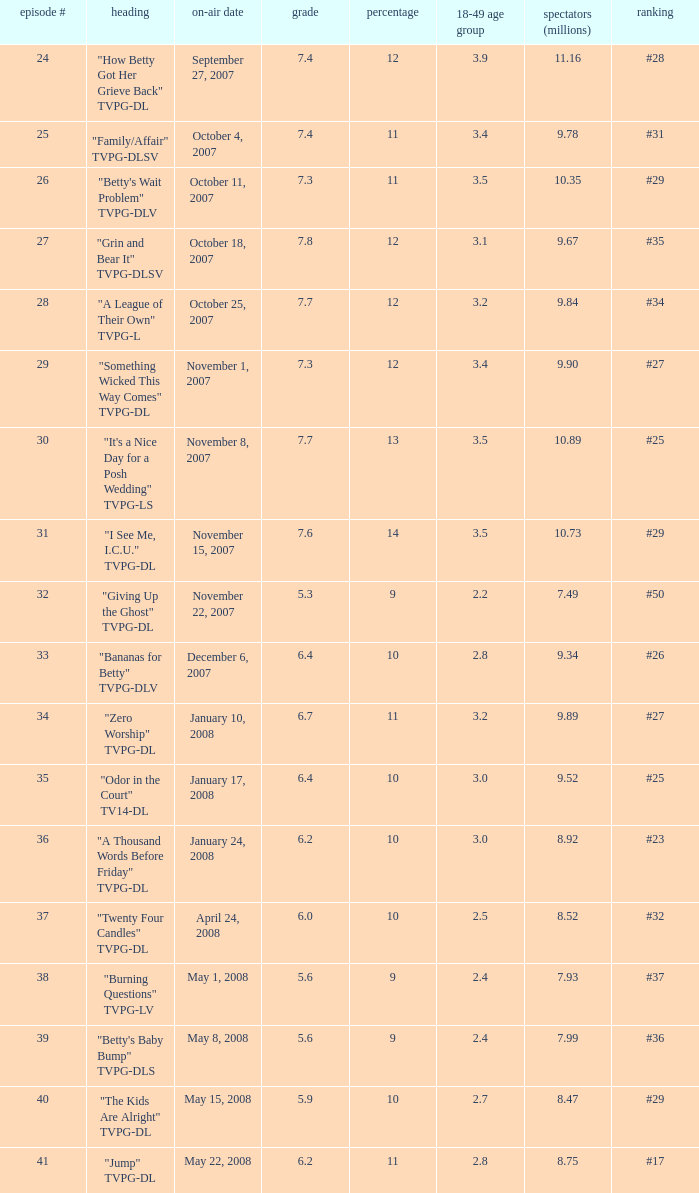What is the Airdate of the episode that ranked #29 and had a share greater than 10? May 15, 2008. 